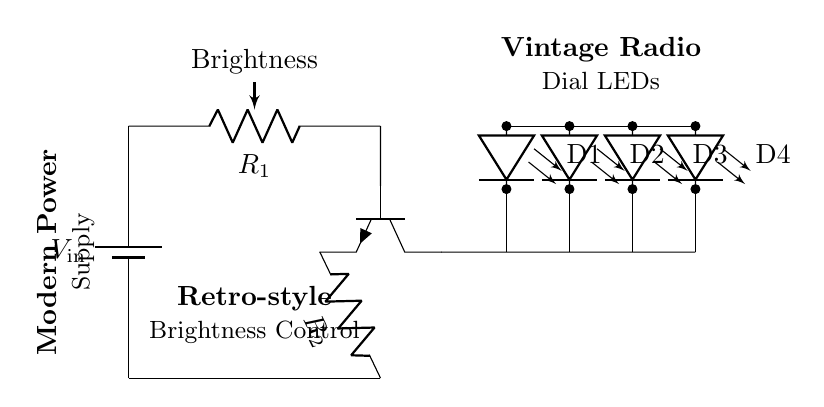What component is used to adjust brightness? The component used to adjust brightness is a potentiometer, labeled as R1 in the circuit diagram.
Answer: potentiometer What type of transistor is shown in the circuit? The transistor depicted in the circuit is an NPN transistor, identified with the notation "npn" in the diagram.
Answer: NPN How many LEDs are there in total? There are four LEDs in the circuit, labeled as D1, D2, D3, and D4.
Answer: four What is the role of the resistor R2? Resistor R2, connected to the emitter of the transistor, helps limit the current flowing to the LEDs, ensuring they do not draw too much current.
Answer: current limiting What is the input voltage represented in the circuit? The input voltage, represented by V_in, is not specified but is shown as a generic voltage supply denoting the power source for the circuit.
Answer: V_in Explain how adjusting the potentiometer affects the brightness of the LEDs. Adjusting the potentiometer changes its resistance, which alters the voltage and current reaching the base of the NPN transistor. This variation affects how much current the transistor allows to flow through to the LED array, thereby changing their brightness.
Answer: brightness control What type of circuit does this diagram represent? The circuit represents a hybrid type that combines modern LED technology with vintage analog design elements, specifically mimicking the warm glow of vintage radio dials.
Answer: hybrid circuit 